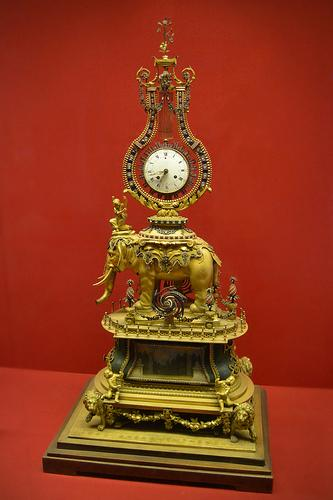How many lion figures are present in the image, and where are they located? There is one lion figure located at the base of the object. Assess the complexity and detail of the image's subject matter. The image is highly complex and detailed, featuring multiple subjects, intricate designs, and various interacting elements. How would you describe the overall sentiment of the image? The image has a majestic and intricate sentiment due to the golden sculpture and detailed features. Identify the primary object and its prominent feature in the image. A large gold clock is the primary object with an elephant on its base as a prominent feature. What is the background of the image mainly composed of? The background consists mainly of red house walls and red house floors. What kind of action is the person in the image performing? The person is balancing on the elephant's head. Describe any areas or elements contributing to the overall appearance of the sculpture. A curved black area, scalloped area trim, garland decorations, and a tiny fence around the elephant contribute to the sculpture's appearance. Explain any unique characteristics of the elephant in the image. The elephant has a decorative saddle on it and long tusks, and a person is balancing on its head. Enumerate the different colors present in the image. Colors in the image include gold, black, red, white, and orange. Point out any animals and their positions in the picture. The animals include an elephant on the clock base, a lion figure at the bottom of the base, and a cherub on the bottom of the base. Can you find lions at the base of the sculpture? If yes, please provide the positional details. Yes, X:229 Y:396 Width:33 Height:33 Is this image related to the topic of time? Yes, there are clocks in the image. Which objects in the image can be considered anomalous? None How does the top of the sculpture appear? Delicate What is the overall sentiment of the image? Positive What can be seen at the top of the sculpture? A large golden clock Describe the sculpture's base. An elephant on the clock base, a lion figure, cherub, and a piece of wood at the bottom. List the objects that interact with the golden elephant. A person on the elephant's head, a decorative saddle, and long tusks What is the position of the elephant on the sculpture? X:82 Y:225 Width:137 Height:137 What color is the wall behind the elephant? Red Find the position and dimensions of the golden humanoid on the base of the object. X:103 Y:368 Width:21 Height:21 Who is sitting on the elephants head? A person Is there a fence in the image? If so, where is it located? Yes, tiny fence around the elephant, X:112 Y:321 Width:118 Height:118 Describe the picture at the bottom of the sculpture. A curved black area on the base, with a scalloped area trim between lions, and a tiny fence around the elephant Rate the quality of the image from 1 to 5, with 5 being the highest. 4 Is there any text in the image that needs to be read? No Identify the primary object in the image. A large gold clock 